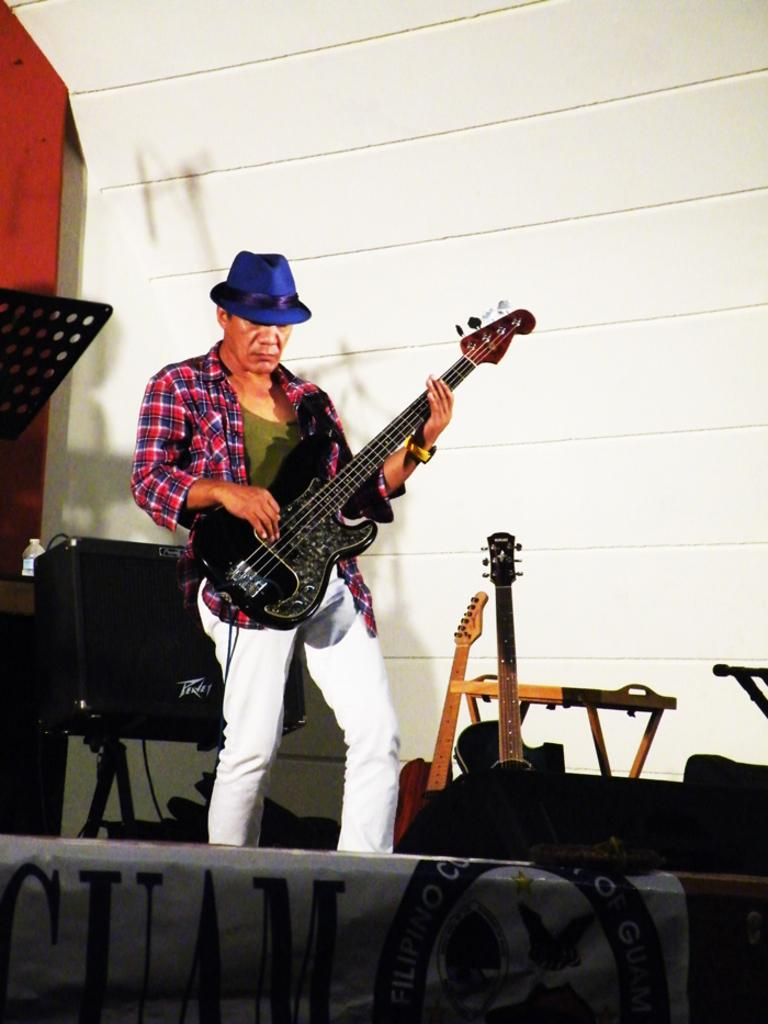What is the man in the image doing? The man is playing a guitar. What is the man wearing on his head? The man is wearing a blue hat. Where is the farm located in the image? There is no farm present in the image. What type of bottle is the man holding in the image? The man is not holding a bottle in the image; he is playing a guitar. 